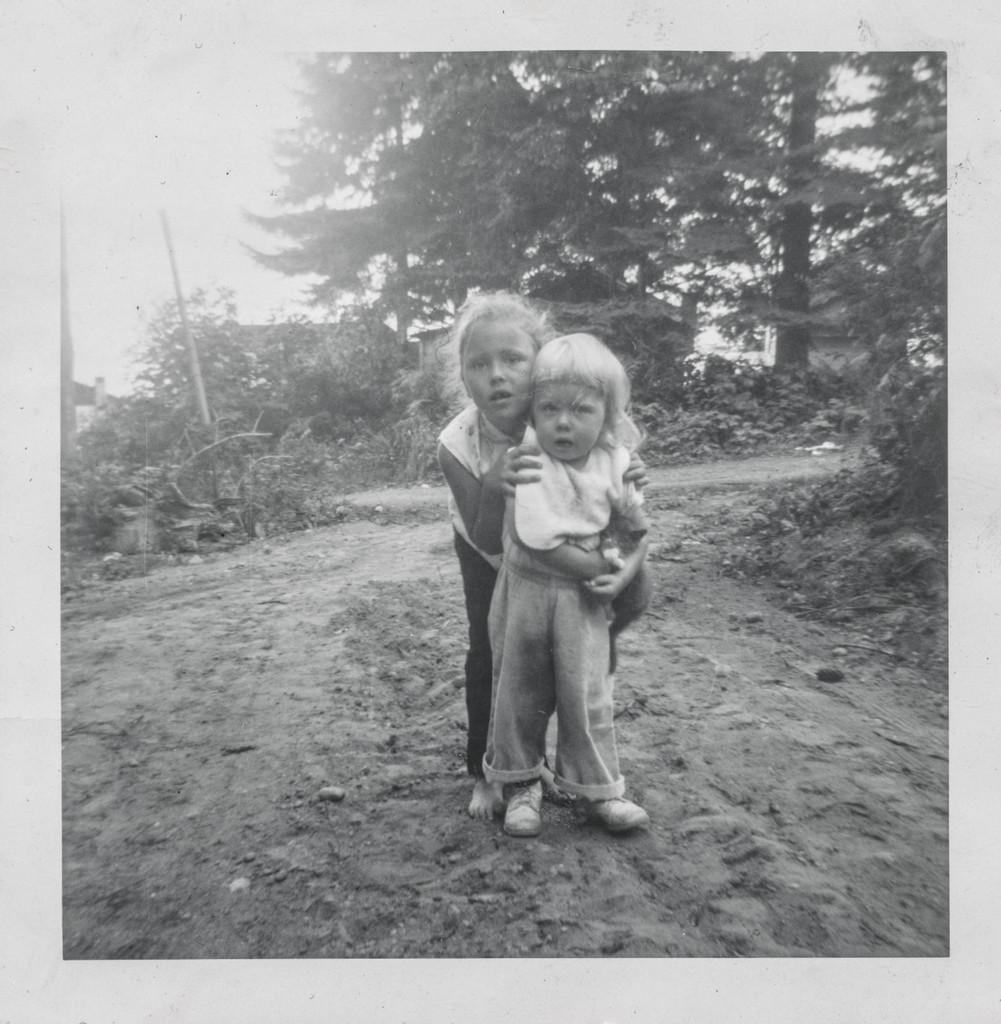In one or two sentences, can you explain what this image depicts? It is the black and white image in which there are two kids who are standing one after the other. In the background there are trees. On the ground there is sand. 